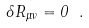Convert formula to latex. <formula><loc_0><loc_0><loc_500><loc_500>\delta R _ { \mu \nu } = 0 \ .</formula> 